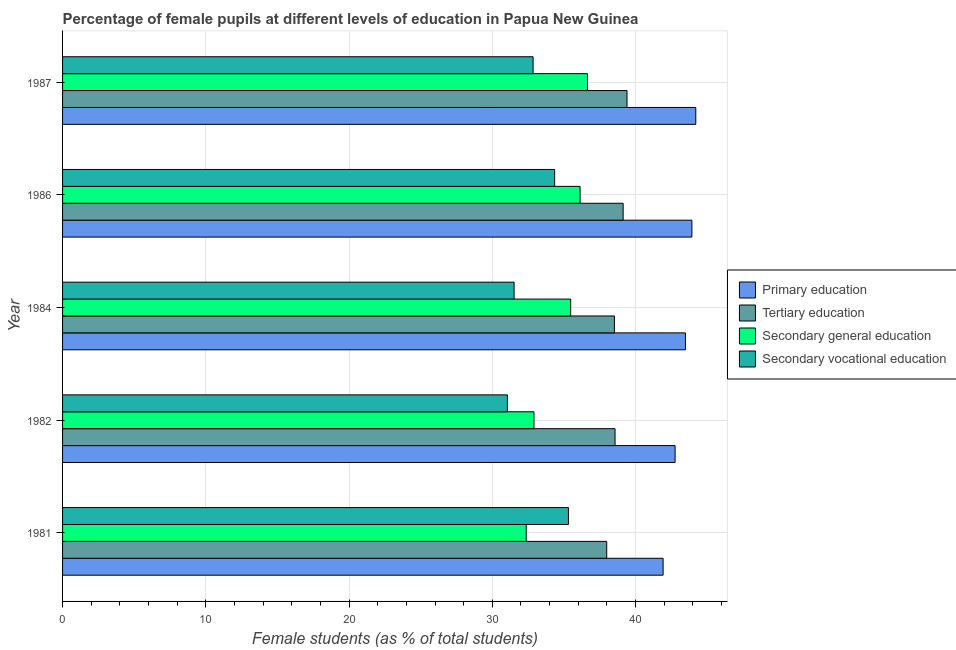How many different coloured bars are there?
Your response must be concise. 4. In how many cases, is the number of bars for a given year not equal to the number of legend labels?
Offer a terse response. 0. What is the percentage of female students in primary education in 1987?
Make the answer very short. 44.2. Across all years, what is the maximum percentage of female students in tertiary education?
Offer a terse response. 39.4. Across all years, what is the minimum percentage of female students in secondary vocational education?
Your response must be concise. 31.05. In which year was the percentage of female students in secondary education maximum?
Ensure brevity in your answer.  1987. What is the total percentage of female students in secondary education in the graph?
Offer a very short reply. 173.52. What is the difference between the percentage of female students in primary education in 1982 and that in 1984?
Offer a terse response. -0.72. What is the difference between the percentage of female students in secondary education in 1982 and the percentage of female students in secondary vocational education in 1981?
Your answer should be very brief. -2.41. What is the average percentage of female students in primary education per year?
Your answer should be very brief. 43.26. In the year 1982, what is the difference between the percentage of female students in secondary vocational education and percentage of female students in primary education?
Provide a short and direct response. -11.71. What is the ratio of the percentage of female students in primary education in 1981 to that in 1986?
Your answer should be very brief. 0.95. Is the percentage of female students in secondary education in 1981 less than that in 1984?
Offer a terse response. Yes. What is the difference between the highest and the second highest percentage of female students in primary education?
Keep it short and to the point. 0.27. What is the difference between the highest and the lowest percentage of female students in secondary vocational education?
Offer a terse response. 4.26. What does the 2nd bar from the top in 1986 represents?
Ensure brevity in your answer.  Secondary general education. What does the 2nd bar from the bottom in 1981 represents?
Ensure brevity in your answer.  Tertiary education. Is it the case that in every year, the sum of the percentage of female students in primary education and percentage of female students in tertiary education is greater than the percentage of female students in secondary education?
Offer a very short reply. Yes. How many bars are there?
Give a very brief answer. 20. How many years are there in the graph?
Keep it short and to the point. 5. What is the difference between two consecutive major ticks on the X-axis?
Keep it short and to the point. 10. Does the graph contain grids?
Provide a short and direct response. Yes. Where does the legend appear in the graph?
Offer a very short reply. Center right. What is the title of the graph?
Provide a succinct answer. Percentage of female pupils at different levels of education in Papua New Guinea. What is the label or title of the X-axis?
Keep it short and to the point. Female students (as % of total students). What is the Female students (as % of total students) in Primary education in 1981?
Give a very brief answer. 41.92. What is the Female students (as % of total students) in Tertiary education in 1981?
Your answer should be compact. 37.99. What is the Female students (as % of total students) in Secondary general education in 1981?
Provide a short and direct response. 32.37. What is the Female students (as % of total students) of Secondary vocational education in 1981?
Keep it short and to the point. 35.31. What is the Female students (as % of total students) in Primary education in 1982?
Ensure brevity in your answer.  42.76. What is the Female students (as % of total students) in Tertiary education in 1982?
Provide a short and direct response. 38.57. What is the Female students (as % of total students) in Secondary general education in 1982?
Provide a short and direct response. 32.91. What is the Female students (as % of total students) of Secondary vocational education in 1982?
Keep it short and to the point. 31.05. What is the Female students (as % of total students) in Primary education in 1984?
Keep it short and to the point. 43.48. What is the Female students (as % of total students) in Tertiary education in 1984?
Give a very brief answer. 38.52. What is the Female students (as % of total students) in Secondary general education in 1984?
Offer a terse response. 35.47. What is the Female students (as % of total students) in Secondary vocational education in 1984?
Offer a terse response. 31.52. What is the Female students (as % of total students) of Primary education in 1986?
Your answer should be compact. 43.93. What is the Female students (as % of total students) in Tertiary education in 1986?
Offer a terse response. 39.13. What is the Female students (as % of total students) of Secondary general education in 1986?
Your response must be concise. 36.13. What is the Female students (as % of total students) in Secondary vocational education in 1986?
Your answer should be very brief. 34.35. What is the Female students (as % of total students) of Primary education in 1987?
Make the answer very short. 44.2. What is the Female students (as % of total students) of Tertiary education in 1987?
Offer a terse response. 39.4. What is the Female students (as % of total students) of Secondary general education in 1987?
Your response must be concise. 36.64. What is the Female students (as % of total students) in Secondary vocational education in 1987?
Provide a short and direct response. 32.85. Across all years, what is the maximum Female students (as % of total students) of Primary education?
Keep it short and to the point. 44.2. Across all years, what is the maximum Female students (as % of total students) of Tertiary education?
Keep it short and to the point. 39.4. Across all years, what is the maximum Female students (as % of total students) in Secondary general education?
Give a very brief answer. 36.64. Across all years, what is the maximum Female students (as % of total students) in Secondary vocational education?
Offer a terse response. 35.31. Across all years, what is the minimum Female students (as % of total students) in Primary education?
Provide a succinct answer. 41.92. Across all years, what is the minimum Female students (as % of total students) in Tertiary education?
Ensure brevity in your answer.  37.99. Across all years, what is the minimum Female students (as % of total students) in Secondary general education?
Ensure brevity in your answer.  32.37. Across all years, what is the minimum Female students (as % of total students) of Secondary vocational education?
Provide a short and direct response. 31.05. What is the total Female students (as % of total students) in Primary education in the graph?
Your answer should be very brief. 216.3. What is the total Female students (as % of total students) of Tertiary education in the graph?
Offer a very short reply. 193.61. What is the total Female students (as % of total students) of Secondary general education in the graph?
Your answer should be compact. 173.52. What is the total Female students (as % of total students) of Secondary vocational education in the graph?
Make the answer very short. 165.08. What is the difference between the Female students (as % of total students) in Primary education in 1981 and that in 1982?
Offer a terse response. -0.84. What is the difference between the Female students (as % of total students) in Tertiary education in 1981 and that in 1982?
Offer a terse response. -0.58. What is the difference between the Female students (as % of total students) of Secondary general education in 1981 and that in 1982?
Offer a terse response. -0.54. What is the difference between the Female students (as % of total students) of Secondary vocational education in 1981 and that in 1982?
Ensure brevity in your answer.  4.26. What is the difference between the Female students (as % of total students) of Primary education in 1981 and that in 1984?
Offer a very short reply. -1.56. What is the difference between the Female students (as % of total students) in Tertiary education in 1981 and that in 1984?
Ensure brevity in your answer.  -0.54. What is the difference between the Female students (as % of total students) of Secondary general education in 1981 and that in 1984?
Provide a succinct answer. -3.1. What is the difference between the Female students (as % of total students) of Secondary vocational education in 1981 and that in 1984?
Your response must be concise. 3.79. What is the difference between the Female students (as % of total students) of Primary education in 1981 and that in 1986?
Give a very brief answer. -2.01. What is the difference between the Female students (as % of total students) of Tertiary education in 1981 and that in 1986?
Your answer should be very brief. -1.15. What is the difference between the Female students (as % of total students) in Secondary general education in 1981 and that in 1986?
Your response must be concise. -3.76. What is the difference between the Female students (as % of total students) of Secondary vocational education in 1981 and that in 1986?
Offer a very short reply. 0.96. What is the difference between the Female students (as % of total students) of Primary education in 1981 and that in 1987?
Ensure brevity in your answer.  -2.28. What is the difference between the Female students (as % of total students) in Tertiary education in 1981 and that in 1987?
Your response must be concise. -1.42. What is the difference between the Female students (as % of total students) in Secondary general education in 1981 and that in 1987?
Provide a short and direct response. -4.28. What is the difference between the Female students (as % of total students) of Secondary vocational education in 1981 and that in 1987?
Provide a short and direct response. 2.47. What is the difference between the Female students (as % of total students) of Primary education in 1982 and that in 1984?
Make the answer very short. -0.72. What is the difference between the Female students (as % of total students) of Tertiary education in 1982 and that in 1984?
Make the answer very short. 0.04. What is the difference between the Female students (as % of total students) in Secondary general education in 1982 and that in 1984?
Keep it short and to the point. -2.56. What is the difference between the Female students (as % of total students) in Secondary vocational education in 1982 and that in 1984?
Make the answer very short. -0.47. What is the difference between the Female students (as % of total students) in Primary education in 1982 and that in 1986?
Your response must be concise. -1.17. What is the difference between the Female students (as % of total students) of Tertiary education in 1982 and that in 1986?
Provide a succinct answer. -0.56. What is the difference between the Female students (as % of total students) in Secondary general education in 1982 and that in 1986?
Make the answer very short. -3.22. What is the difference between the Female students (as % of total students) in Secondary vocational education in 1982 and that in 1986?
Provide a succinct answer. -3.3. What is the difference between the Female students (as % of total students) in Primary education in 1982 and that in 1987?
Provide a short and direct response. -1.44. What is the difference between the Female students (as % of total students) in Tertiary education in 1982 and that in 1987?
Ensure brevity in your answer.  -0.84. What is the difference between the Female students (as % of total students) of Secondary general education in 1982 and that in 1987?
Provide a succinct answer. -3.73. What is the difference between the Female students (as % of total students) in Secondary vocational education in 1982 and that in 1987?
Provide a short and direct response. -1.79. What is the difference between the Female students (as % of total students) of Primary education in 1984 and that in 1986?
Offer a terse response. -0.45. What is the difference between the Female students (as % of total students) in Tertiary education in 1984 and that in 1986?
Provide a short and direct response. -0.61. What is the difference between the Female students (as % of total students) in Secondary general education in 1984 and that in 1986?
Your answer should be compact. -0.66. What is the difference between the Female students (as % of total students) of Secondary vocational education in 1984 and that in 1986?
Provide a succinct answer. -2.83. What is the difference between the Female students (as % of total students) of Primary education in 1984 and that in 1987?
Your answer should be compact. -0.72. What is the difference between the Female students (as % of total students) of Tertiary education in 1984 and that in 1987?
Give a very brief answer. -0.88. What is the difference between the Female students (as % of total students) in Secondary general education in 1984 and that in 1987?
Offer a terse response. -1.17. What is the difference between the Female students (as % of total students) in Secondary vocational education in 1984 and that in 1987?
Your answer should be compact. -1.32. What is the difference between the Female students (as % of total students) in Primary education in 1986 and that in 1987?
Give a very brief answer. -0.27. What is the difference between the Female students (as % of total students) of Tertiary education in 1986 and that in 1987?
Your answer should be compact. -0.27. What is the difference between the Female students (as % of total students) in Secondary general education in 1986 and that in 1987?
Ensure brevity in your answer.  -0.52. What is the difference between the Female students (as % of total students) of Secondary vocational education in 1986 and that in 1987?
Keep it short and to the point. 1.5. What is the difference between the Female students (as % of total students) of Primary education in 1981 and the Female students (as % of total students) of Tertiary education in 1982?
Your answer should be compact. 3.35. What is the difference between the Female students (as % of total students) of Primary education in 1981 and the Female students (as % of total students) of Secondary general education in 1982?
Your response must be concise. 9.01. What is the difference between the Female students (as % of total students) in Primary education in 1981 and the Female students (as % of total students) in Secondary vocational education in 1982?
Offer a very short reply. 10.87. What is the difference between the Female students (as % of total students) in Tertiary education in 1981 and the Female students (as % of total students) in Secondary general education in 1982?
Your response must be concise. 5.08. What is the difference between the Female students (as % of total students) of Tertiary education in 1981 and the Female students (as % of total students) of Secondary vocational education in 1982?
Your response must be concise. 6.93. What is the difference between the Female students (as % of total students) in Secondary general education in 1981 and the Female students (as % of total students) in Secondary vocational education in 1982?
Give a very brief answer. 1.32. What is the difference between the Female students (as % of total students) in Primary education in 1981 and the Female students (as % of total students) in Tertiary education in 1984?
Keep it short and to the point. 3.4. What is the difference between the Female students (as % of total students) in Primary education in 1981 and the Female students (as % of total students) in Secondary general education in 1984?
Your answer should be compact. 6.45. What is the difference between the Female students (as % of total students) of Primary education in 1981 and the Female students (as % of total students) of Secondary vocational education in 1984?
Offer a very short reply. 10.4. What is the difference between the Female students (as % of total students) of Tertiary education in 1981 and the Female students (as % of total students) of Secondary general education in 1984?
Your answer should be very brief. 2.52. What is the difference between the Female students (as % of total students) in Tertiary education in 1981 and the Female students (as % of total students) in Secondary vocational education in 1984?
Provide a succinct answer. 6.46. What is the difference between the Female students (as % of total students) in Secondary general education in 1981 and the Female students (as % of total students) in Secondary vocational education in 1984?
Your answer should be compact. 0.85. What is the difference between the Female students (as % of total students) of Primary education in 1981 and the Female students (as % of total students) of Tertiary education in 1986?
Make the answer very short. 2.79. What is the difference between the Female students (as % of total students) in Primary education in 1981 and the Female students (as % of total students) in Secondary general education in 1986?
Keep it short and to the point. 5.8. What is the difference between the Female students (as % of total students) in Primary education in 1981 and the Female students (as % of total students) in Secondary vocational education in 1986?
Provide a succinct answer. 7.57. What is the difference between the Female students (as % of total students) in Tertiary education in 1981 and the Female students (as % of total students) in Secondary general education in 1986?
Your answer should be very brief. 1.86. What is the difference between the Female students (as % of total students) of Tertiary education in 1981 and the Female students (as % of total students) of Secondary vocational education in 1986?
Your answer should be very brief. 3.64. What is the difference between the Female students (as % of total students) in Secondary general education in 1981 and the Female students (as % of total students) in Secondary vocational education in 1986?
Provide a short and direct response. -1.98. What is the difference between the Female students (as % of total students) of Primary education in 1981 and the Female students (as % of total students) of Tertiary education in 1987?
Offer a terse response. 2.52. What is the difference between the Female students (as % of total students) of Primary education in 1981 and the Female students (as % of total students) of Secondary general education in 1987?
Give a very brief answer. 5.28. What is the difference between the Female students (as % of total students) of Primary education in 1981 and the Female students (as % of total students) of Secondary vocational education in 1987?
Offer a terse response. 9.08. What is the difference between the Female students (as % of total students) in Tertiary education in 1981 and the Female students (as % of total students) in Secondary general education in 1987?
Ensure brevity in your answer.  1.34. What is the difference between the Female students (as % of total students) of Tertiary education in 1981 and the Female students (as % of total students) of Secondary vocational education in 1987?
Your answer should be very brief. 5.14. What is the difference between the Female students (as % of total students) in Secondary general education in 1981 and the Female students (as % of total students) in Secondary vocational education in 1987?
Make the answer very short. -0.48. What is the difference between the Female students (as % of total students) of Primary education in 1982 and the Female students (as % of total students) of Tertiary education in 1984?
Make the answer very short. 4.24. What is the difference between the Female students (as % of total students) of Primary education in 1982 and the Female students (as % of total students) of Secondary general education in 1984?
Offer a very short reply. 7.29. What is the difference between the Female students (as % of total students) of Primary education in 1982 and the Female students (as % of total students) of Secondary vocational education in 1984?
Offer a terse response. 11.24. What is the difference between the Female students (as % of total students) in Tertiary education in 1982 and the Female students (as % of total students) in Secondary general education in 1984?
Provide a short and direct response. 3.1. What is the difference between the Female students (as % of total students) in Tertiary education in 1982 and the Female students (as % of total students) in Secondary vocational education in 1984?
Offer a very short reply. 7.05. What is the difference between the Female students (as % of total students) of Secondary general education in 1982 and the Female students (as % of total students) of Secondary vocational education in 1984?
Your answer should be compact. 1.39. What is the difference between the Female students (as % of total students) in Primary education in 1982 and the Female students (as % of total students) in Tertiary education in 1986?
Provide a short and direct response. 3.63. What is the difference between the Female students (as % of total students) of Primary education in 1982 and the Female students (as % of total students) of Secondary general education in 1986?
Make the answer very short. 6.63. What is the difference between the Female students (as % of total students) in Primary education in 1982 and the Female students (as % of total students) in Secondary vocational education in 1986?
Keep it short and to the point. 8.41. What is the difference between the Female students (as % of total students) of Tertiary education in 1982 and the Female students (as % of total students) of Secondary general education in 1986?
Ensure brevity in your answer.  2.44. What is the difference between the Female students (as % of total students) in Tertiary education in 1982 and the Female students (as % of total students) in Secondary vocational education in 1986?
Offer a very short reply. 4.22. What is the difference between the Female students (as % of total students) of Secondary general education in 1982 and the Female students (as % of total students) of Secondary vocational education in 1986?
Give a very brief answer. -1.44. What is the difference between the Female students (as % of total students) of Primary education in 1982 and the Female students (as % of total students) of Tertiary education in 1987?
Ensure brevity in your answer.  3.36. What is the difference between the Female students (as % of total students) of Primary education in 1982 and the Female students (as % of total students) of Secondary general education in 1987?
Offer a very short reply. 6.12. What is the difference between the Female students (as % of total students) in Primary education in 1982 and the Female students (as % of total students) in Secondary vocational education in 1987?
Keep it short and to the point. 9.91. What is the difference between the Female students (as % of total students) of Tertiary education in 1982 and the Female students (as % of total students) of Secondary general education in 1987?
Offer a terse response. 1.92. What is the difference between the Female students (as % of total students) of Tertiary education in 1982 and the Female students (as % of total students) of Secondary vocational education in 1987?
Your response must be concise. 5.72. What is the difference between the Female students (as % of total students) in Secondary general education in 1982 and the Female students (as % of total students) in Secondary vocational education in 1987?
Keep it short and to the point. 0.06. What is the difference between the Female students (as % of total students) of Primary education in 1984 and the Female students (as % of total students) of Tertiary education in 1986?
Provide a short and direct response. 4.35. What is the difference between the Female students (as % of total students) in Primary education in 1984 and the Female students (as % of total students) in Secondary general education in 1986?
Offer a very short reply. 7.36. What is the difference between the Female students (as % of total students) of Primary education in 1984 and the Female students (as % of total students) of Secondary vocational education in 1986?
Offer a very short reply. 9.13. What is the difference between the Female students (as % of total students) in Tertiary education in 1984 and the Female students (as % of total students) in Secondary general education in 1986?
Provide a short and direct response. 2.4. What is the difference between the Female students (as % of total students) of Tertiary education in 1984 and the Female students (as % of total students) of Secondary vocational education in 1986?
Your answer should be compact. 4.17. What is the difference between the Female students (as % of total students) in Secondary general education in 1984 and the Female students (as % of total students) in Secondary vocational education in 1986?
Your answer should be compact. 1.12. What is the difference between the Female students (as % of total students) in Primary education in 1984 and the Female students (as % of total students) in Tertiary education in 1987?
Your response must be concise. 4.08. What is the difference between the Female students (as % of total students) of Primary education in 1984 and the Female students (as % of total students) of Secondary general education in 1987?
Your answer should be compact. 6.84. What is the difference between the Female students (as % of total students) of Primary education in 1984 and the Female students (as % of total students) of Secondary vocational education in 1987?
Ensure brevity in your answer.  10.64. What is the difference between the Female students (as % of total students) in Tertiary education in 1984 and the Female students (as % of total students) in Secondary general education in 1987?
Offer a terse response. 1.88. What is the difference between the Female students (as % of total students) of Tertiary education in 1984 and the Female students (as % of total students) of Secondary vocational education in 1987?
Make the answer very short. 5.68. What is the difference between the Female students (as % of total students) of Secondary general education in 1984 and the Female students (as % of total students) of Secondary vocational education in 1987?
Give a very brief answer. 2.62. What is the difference between the Female students (as % of total students) in Primary education in 1986 and the Female students (as % of total students) in Tertiary education in 1987?
Provide a short and direct response. 4.53. What is the difference between the Female students (as % of total students) in Primary education in 1986 and the Female students (as % of total students) in Secondary general education in 1987?
Offer a very short reply. 7.29. What is the difference between the Female students (as % of total students) in Primary education in 1986 and the Female students (as % of total students) in Secondary vocational education in 1987?
Keep it short and to the point. 11.09. What is the difference between the Female students (as % of total students) of Tertiary education in 1986 and the Female students (as % of total students) of Secondary general education in 1987?
Offer a terse response. 2.49. What is the difference between the Female students (as % of total students) in Tertiary education in 1986 and the Female students (as % of total students) in Secondary vocational education in 1987?
Provide a succinct answer. 6.29. What is the difference between the Female students (as % of total students) in Secondary general education in 1986 and the Female students (as % of total students) in Secondary vocational education in 1987?
Keep it short and to the point. 3.28. What is the average Female students (as % of total students) in Primary education per year?
Your answer should be very brief. 43.26. What is the average Female students (as % of total students) in Tertiary education per year?
Offer a terse response. 38.72. What is the average Female students (as % of total students) in Secondary general education per year?
Provide a succinct answer. 34.7. What is the average Female students (as % of total students) of Secondary vocational education per year?
Ensure brevity in your answer.  33.02. In the year 1981, what is the difference between the Female students (as % of total students) in Primary education and Female students (as % of total students) in Tertiary education?
Provide a short and direct response. 3.94. In the year 1981, what is the difference between the Female students (as % of total students) of Primary education and Female students (as % of total students) of Secondary general education?
Provide a short and direct response. 9.55. In the year 1981, what is the difference between the Female students (as % of total students) of Primary education and Female students (as % of total students) of Secondary vocational education?
Offer a terse response. 6.61. In the year 1981, what is the difference between the Female students (as % of total students) in Tertiary education and Female students (as % of total students) in Secondary general education?
Provide a short and direct response. 5.62. In the year 1981, what is the difference between the Female students (as % of total students) of Tertiary education and Female students (as % of total students) of Secondary vocational education?
Provide a succinct answer. 2.67. In the year 1981, what is the difference between the Female students (as % of total students) in Secondary general education and Female students (as % of total students) in Secondary vocational education?
Offer a very short reply. -2.95. In the year 1982, what is the difference between the Female students (as % of total students) of Primary education and Female students (as % of total students) of Tertiary education?
Provide a succinct answer. 4.19. In the year 1982, what is the difference between the Female students (as % of total students) in Primary education and Female students (as % of total students) in Secondary general education?
Offer a terse response. 9.85. In the year 1982, what is the difference between the Female students (as % of total students) in Primary education and Female students (as % of total students) in Secondary vocational education?
Provide a succinct answer. 11.71. In the year 1982, what is the difference between the Female students (as % of total students) in Tertiary education and Female students (as % of total students) in Secondary general education?
Your response must be concise. 5.66. In the year 1982, what is the difference between the Female students (as % of total students) of Tertiary education and Female students (as % of total students) of Secondary vocational education?
Provide a short and direct response. 7.52. In the year 1982, what is the difference between the Female students (as % of total students) in Secondary general education and Female students (as % of total students) in Secondary vocational education?
Keep it short and to the point. 1.86. In the year 1984, what is the difference between the Female students (as % of total students) of Primary education and Female students (as % of total students) of Tertiary education?
Offer a terse response. 4.96. In the year 1984, what is the difference between the Female students (as % of total students) in Primary education and Female students (as % of total students) in Secondary general education?
Provide a succinct answer. 8.01. In the year 1984, what is the difference between the Female students (as % of total students) of Primary education and Female students (as % of total students) of Secondary vocational education?
Your answer should be compact. 11.96. In the year 1984, what is the difference between the Female students (as % of total students) of Tertiary education and Female students (as % of total students) of Secondary general education?
Offer a terse response. 3.05. In the year 1984, what is the difference between the Female students (as % of total students) in Tertiary education and Female students (as % of total students) in Secondary vocational education?
Offer a very short reply. 7. In the year 1984, what is the difference between the Female students (as % of total students) in Secondary general education and Female students (as % of total students) in Secondary vocational education?
Provide a short and direct response. 3.95. In the year 1986, what is the difference between the Female students (as % of total students) in Primary education and Female students (as % of total students) in Tertiary education?
Provide a short and direct response. 4.8. In the year 1986, what is the difference between the Female students (as % of total students) of Primary education and Female students (as % of total students) of Secondary general education?
Your answer should be compact. 7.81. In the year 1986, what is the difference between the Female students (as % of total students) of Primary education and Female students (as % of total students) of Secondary vocational education?
Provide a short and direct response. 9.58. In the year 1986, what is the difference between the Female students (as % of total students) in Tertiary education and Female students (as % of total students) in Secondary general education?
Offer a terse response. 3.01. In the year 1986, what is the difference between the Female students (as % of total students) in Tertiary education and Female students (as % of total students) in Secondary vocational education?
Keep it short and to the point. 4.78. In the year 1986, what is the difference between the Female students (as % of total students) of Secondary general education and Female students (as % of total students) of Secondary vocational education?
Offer a terse response. 1.78. In the year 1987, what is the difference between the Female students (as % of total students) of Primary education and Female students (as % of total students) of Tertiary education?
Ensure brevity in your answer.  4.8. In the year 1987, what is the difference between the Female students (as % of total students) of Primary education and Female students (as % of total students) of Secondary general education?
Your answer should be very brief. 7.56. In the year 1987, what is the difference between the Female students (as % of total students) of Primary education and Female students (as % of total students) of Secondary vocational education?
Make the answer very short. 11.36. In the year 1987, what is the difference between the Female students (as % of total students) of Tertiary education and Female students (as % of total students) of Secondary general education?
Your answer should be very brief. 2.76. In the year 1987, what is the difference between the Female students (as % of total students) of Tertiary education and Female students (as % of total students) of Secondary vocational education?
Your answer should be very brief. 6.56. In the year 1987, what is the difference between the Female students (as % of total students) in Secondary general education and Female students (as % of total students) in Secondary vocational education?
Ensure brevity in your answer.  3.8. What is the ratio of the Female students (as % of total students) of Primary education in 1981 to that in 1982?
Keep it short and to the point. 0.98. What is the ratio of the Female students (as % of total students) of Tertiary education in 1981 to that in 1982?
Your response must be concise. 0.98. What is the ratio of the Female students (as % of total students) of Secondary general education in 1981 to that in 1982?
Keep it short and to the point. 0.98. What is the ratio of the Female students (as % of total students) of Secondary vocational education in 1981 to that in 1982?
Your answer should be compact. 1.14. What is the ratio of the Female students (as % of total students) of Primary education in 1981 to that in 1984?
Offer a terse response. 0.96. What is the ratio of the Female students (as % of total students) in Tertiary education in 1981 to that in 1984?
Provide a short and direct response. 0.99. What is the ratio of the Female students (as % of total students) in Secondary general education in 1981 to that in 1984?
Offer a terse response. 0.91. What is the ratio of the Female students (as % of total students) in Secondary vocational education in 1981 to that in 1984?
Give a very brief answer. 1.12. What is the ratio of the Female students (as % of total students) of Primary education in 1981 to that in 1986?
Provide a short and direct response. 0.95. What is the ratio of the Female students (as % of total students) in Tertiary education in 1981 to that in 1986?
Offer a very short reply. 0.97. What is the ratio of the Female students (as % of total students) of Secondary general education in 1981 to that in 1986?
Give a very brief answer. 0.9. What is the ratio of the Female students (as % of total students) in Secondary vocational education in 1981 to that in 1986?
Offer a terse response. 1.03. What is the ratio of the Female students (as % of total students) of Primary education in 1981 to that in 1987?
Provide a succinct answer. 0.95. What is the ratio of the Female students (as % of total students) in Secondary general education in 1981 to that in 1987?
Keep it short and to the point. 0.88. What is the ratio of the Female students (as % of total students) in Secondary vocational education in 1981 to that in 1987?
Provide a short and direct response. 1.08. What is the ratio of the Female students (as % of total students) in Primary education in 1982 to that in 1984?
Ensure brevity in your answer.  0.98. What is the ratio of the Female students (as % of total students) in Tertiary education in 1982 to that in 1984?
Give a very brief answer. 1. What is the ratio of the Female students (as % of total students) of Secondary general education in 1982 to that in 1984?
Ensure brevity in your answer.  0.93. What is the ratio of the Female students (as % of total students) of Secondary vocational education in 1982 to that in 1984?
Your answer should be compact. 0.99. What is the ratio of the Female students (as % of total students) in Primary education in 1982 to that in 1986?
Provide a short and direct response. 0.97. What is the ratio of the Female students (as % of total students) in Tertiary education in 1982 to that in 1986?
Keep it short and to the point. 0.99. What is the ratio of the Female students (as % of total students) in Secondary general education in 1982 to that in 1986?
Your response must be concise. 0.91. What is the ratio of the Female students (as % of total students) of Secondary vocational education in 1982 to that in 1986?
Provide a short and direct response. 0.9. What is the ratio of the Female students (as % of total students) in Primary education in 1982 to that in 1987?
Make the answer very short. 0.97. What is the ratio of the Female students (as % of total students) in Tertiary education in 1982 to that in 1987?
Your response must be concise. 0.98. What is the ratio of the Female students (as % of total students) of Secondary general education in 1982 to that in 1987?
Provide a succinct answer. 0.9. What is the ratio of the Female students (as % of total students) of Secondary vocational education in 1982 to that in 1987?
Offer a very short reply. 0.95. What is the ratio of the Female students (as % of total students) of Primary education in 1984 to that in 1986?
Give a very brief answer. 0.99. What is the ratio of the Female students (as % of total students) in Tertiary education in 1984 to that in 1986?
Offer a very short reply. 0.98. What is the ratio of the Female students (as % of total students) in Secondary general education in 1984 to that in 1986?
Your response must be concise. 0.98. What is the ratio of the Female students (as % of total students) of Secondary vocational education in 1984 to that in 1986?
Provide a short and direct response. 0.92. What is the ratio of the Female students (as % of total students) of Primary education in 1984 to that in 1987?
Keep it short and to the point. 0.98. What is the ratio of the Female students (as % of total students) of Tertiary education in 1984 to that in 1987?
Keep it short and to the point. 0.98. What is the ratio of the Female students (as % of total students) of Secondary general education in 1984 to that in 1987?
Give a very brief answer. 0.97. What is the ratio of the Female students (as % of total students) of Secondary vocational education in 1984 to that in 1987?
Provide a succinct answer. 0.96. What is the ratio of the Female students (as % of total students) of Tertiary education in 1986 to that in 1987?
Provide a short and direct response. 0.99. What is the ratio of the Female students (as % of total students) in Secondary general education in 1986 to that in 1987?
Provide a short and direct response. 0.99. What is the ratio of the Female students (as % of total students) of Secondary vocational education in 1986 to that in 1987?
Your answer should be very brief. 1.05. What is the difference between the highest and the second highest Female students (as % of total students) in Primary education?
Provide a succinct answer. 0.27. What is the difference between the highest and the second highest Female students (as % of total students) in Tertiary education?
Offer a very short reply. 0.27. What is the difference between the highest and the second highest Female students (as % of total students) in Secondary general education?
Your response must be concise. 0.52. What is the difference between the highest and the second highest Female students (as % of total students) of Secondary vocational education?
Your answer should be compact. 0.96. What is the difference between the highest and the lowest Female students (as % of total students) in Primary education?
Your answer should be compact. 2.28. What is the difference between the highest and the lowest Female students (as % of total students) of Tertiary education?
Your answer should be compact. 1.42. What is the difference between the highest and the lowest Female students (as % of total students) in Secondary general education?
Ensure brevity in your answer.  4.28. What is the difference between the highest and the lowest Female students (as % of total students) of Secondary vocational education?
Provide a succinct answer. 4.26. 